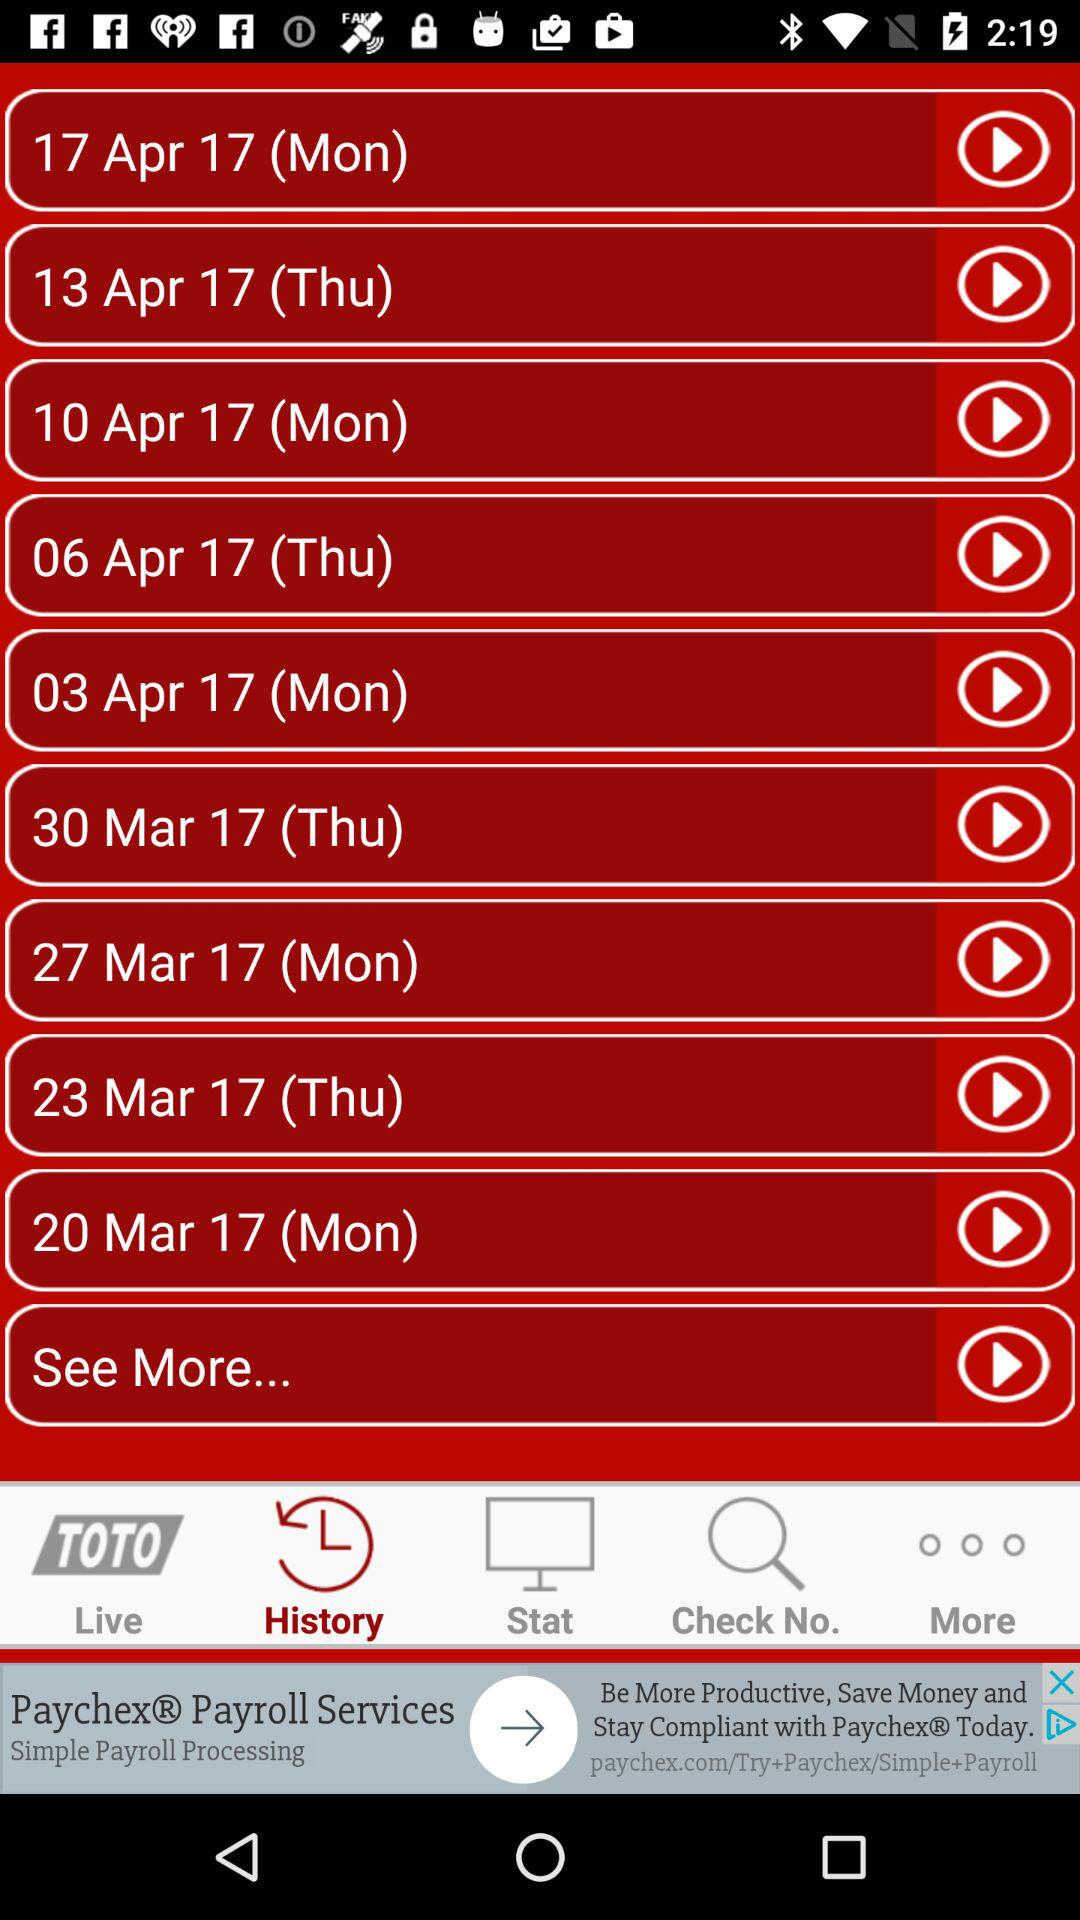Which tab has been selected? The tab that has been selected is "History". 